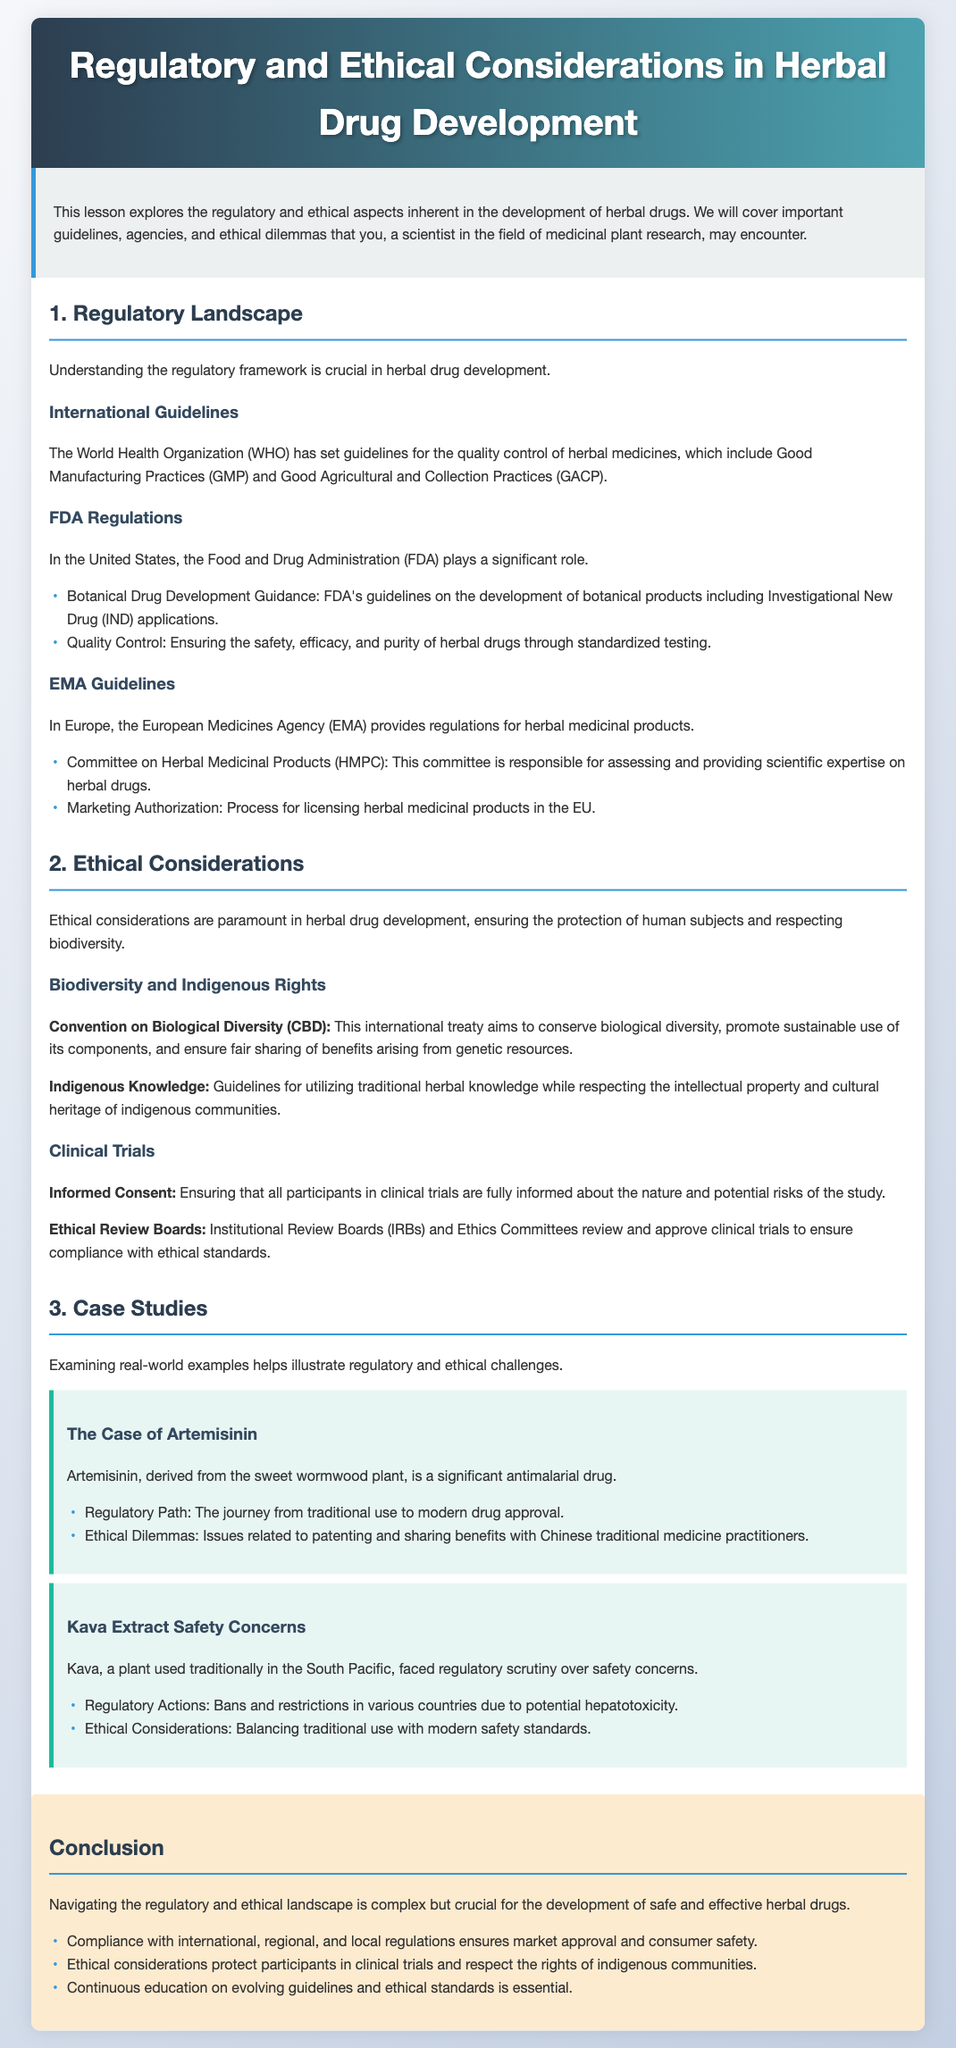What are the WHO guidelines for herbal medicines? The World Health Organization's guidelines for herbal medicines include Good Manufacturing Practices (GMP) and Good Agricultural and Collection Practices (GACP).
Answer: GMP and GACP Which US agency regulates herbal drug development? The agency in the United States that regulates herbal drug development is the Food and Drug Administration.
Answer: Food and Drug Administration What is the role of the HMPC? The Committee on Herbal Medicinal Products (HMPC) is responsible for assessing and providing scientific expertise on herbal drugs in Europe.
Answer: Assessing and providing expertise What does CBD stand for in the context of ethics? CBD stands for Convention on Biological Diversity, which is an international treaty related to biodiversity.
Answer: Convention on Biological Diversity What is required from participants in clinical trials according to ethical guidelines? According to ethical guidelines, informed consent is required from participants in clinical trials.
Answer: Informed consent How many case studies are mentioned in the lesson? There are two case studies mentioned in the lesson: The Case of Artemisinin and Kava Extract Safety Concerns.
Answer: Two What are the main ethical considerations in herbal drug development? The main ethical considerations include protecting human subjects and respecting biodiversity.
Answer: Protecting human subjects and respecting biodiversity What is the conclusion regarding regulatory and ethical navigation? The conclusion emphasizes that navigating the regulatory and ethical landscape is complex but crucial for safe and effective herbal drug development.
Answer: Complex but crucial What does the document primarily explore? The document primarily explores regulatory and ethical aspects in the development of herbal drugs.
Answer: Regulatory and ethical aspects 